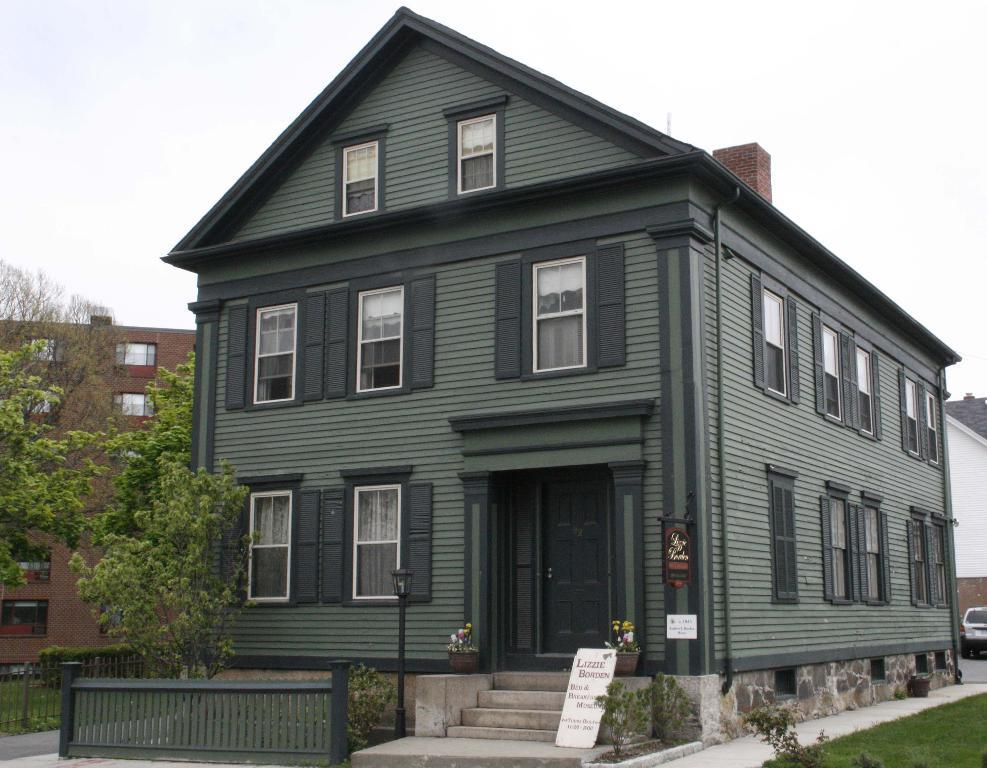What type of structures can be seen in the image? There are buildings in the image. What type of vegetation is present in the image? There are trees, plants, and grass in the image. What type of barrier can be seen in the image? There is a fence in the image. What is visible in the background of the image? There is a vehicle and the sky visible in the background of the image. What level of the building is the car parked on in the image? There is no car present in the image; it is a vehicle in the background. How many rooms can be seen in the image? There is no room visible in the image; it features buildings, trees, plants, grass, a fence, a vehicle, and the sky. 